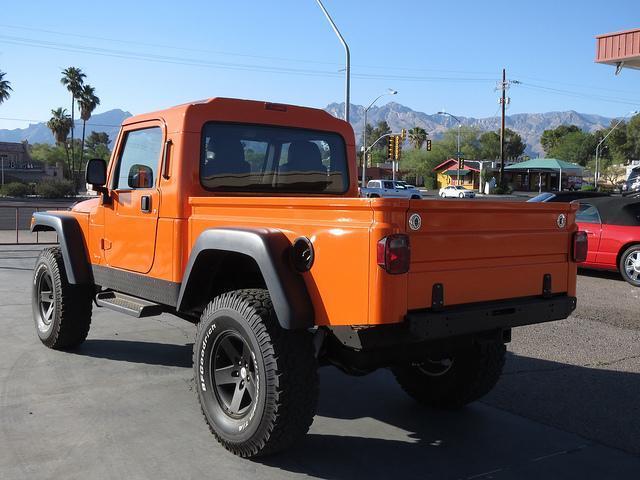How many cars are there?
Give a very brief answer. 1. How many people in the photo are carrying surfboards?
Give a very brief answer. 0. 